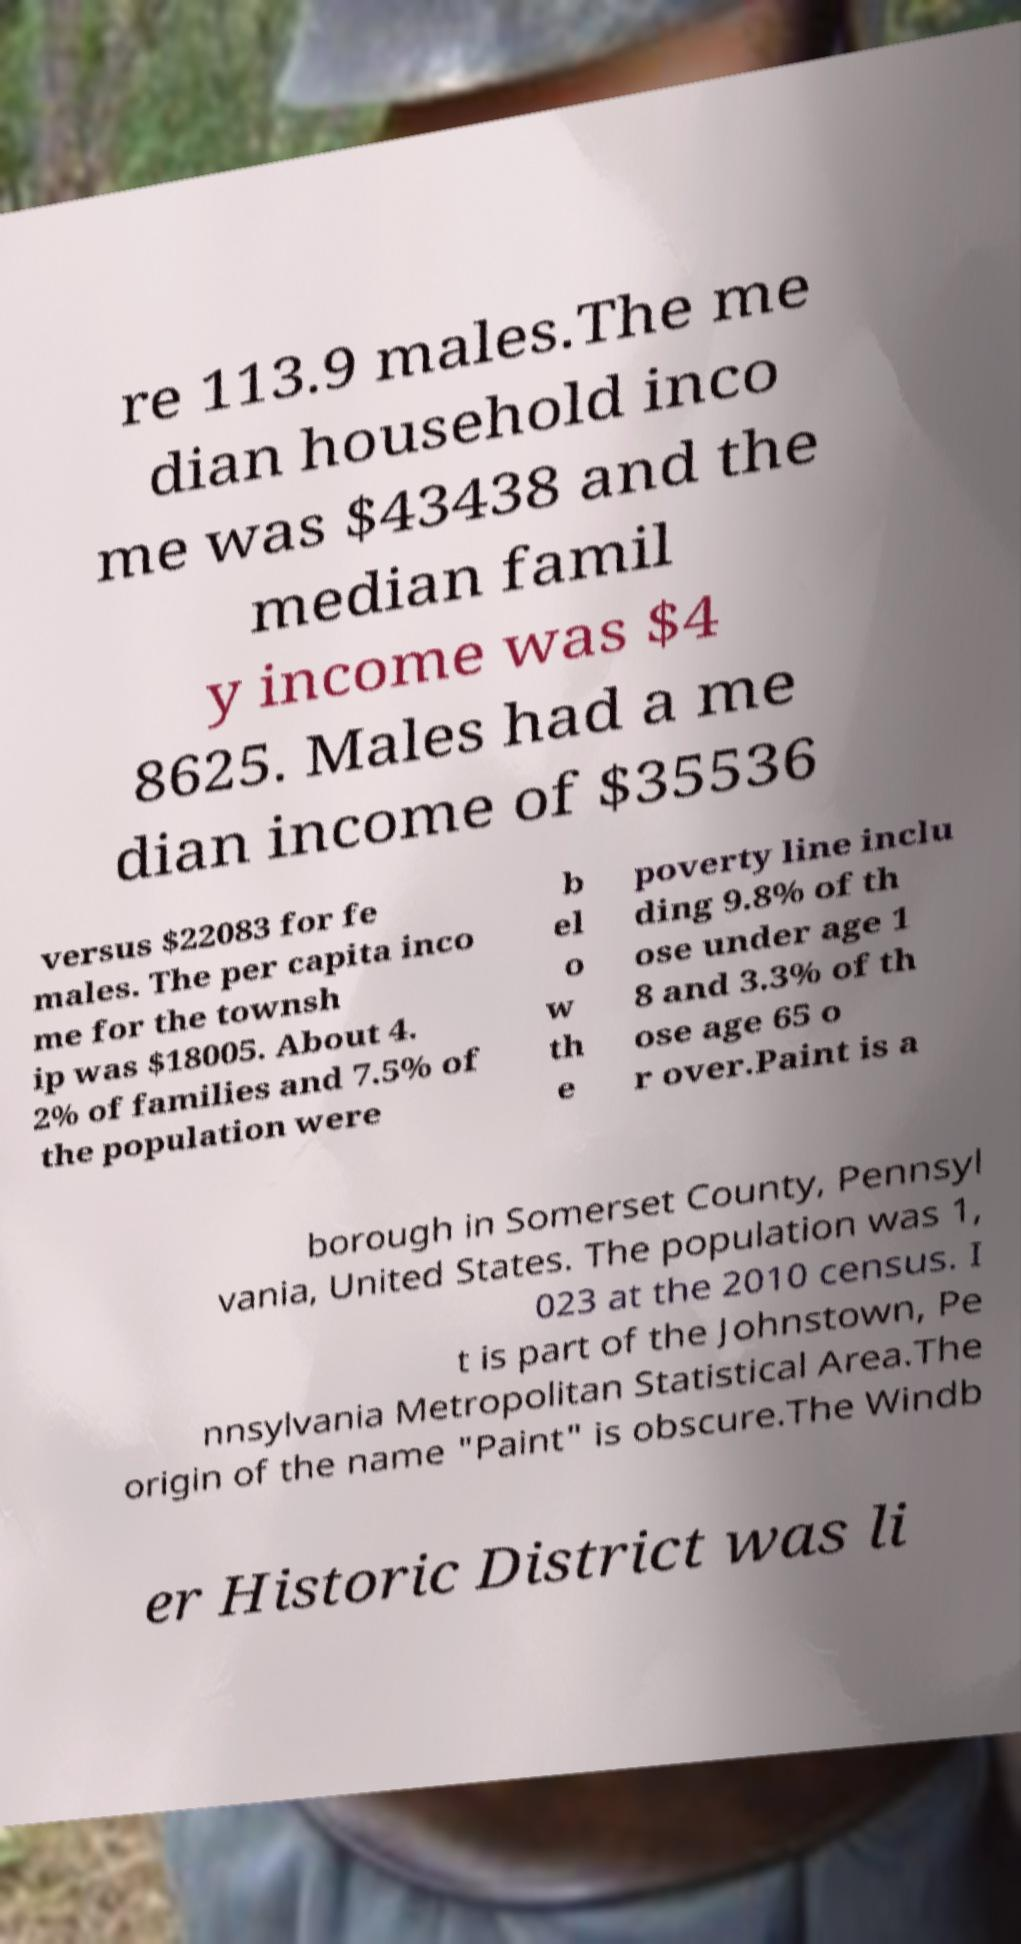Can you read and provide the text displayed in the image?This photo seems to have some interesting text. Can you extract and type it out for me? re 113.9 males.The me dian household inco me was $43438 and the median famil y income was $4 8625. Males had a me dian income of $35536 versus $22083 for fe males. The per capita inco me for the townsh ip was $18005. About 4. 2% of families and 7.5% of the population were b el o w th e poverty line inclu ding 9.8% of th ose under age 1 8 and 3.3% of th ose age 65 o r over.Paint is a borough in Somerset County, Pennsyl vania, United States. The population was 1, 023 at the 2010 census. I t is part of the Johnstown, Pe nnsylvania Metropolitan Statistical Area.The origin of the name "Paint" is obscure.The Windb er Historic District was li 